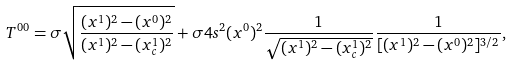Convert formula to latex. <formula><loc_0><loc_0><loc_500><loc_500>T ^ { 0 0 } = \sigma \sqrt { \frac { ( x ^ { 1 } ) ^ { 2 } - ( x ^ { 0 } ) ^ { 2 } } { ( x ^ { 1 } ) ^ { 2 } - ( x ^ { 1 } _ { c } ) ^ { 2 } } } + \sigma 4 s ^ { 2 } ( x ^ { 0 } ) ^ { 2 } \frac { 1 } { \sqrt { ( x ^ { 1 } ) ^ { 2 } - ( x ^ { 1 } _ { c } ) ^ { 2 } } } \frac { 1 } { [ ( x ^ { 1 } ) ^ { 2 } - ( x ^ { 0 } ) ^ { 2 } ] ^ { 3 / 2 } } ,</formula> 